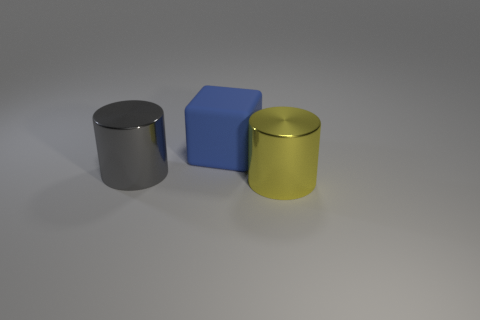Subtract all cubes. How many objects are left? 2 Subtract 1 cylinders. How many cylinders are left? 1 Add 3 large brown matte cylinders. How many objects exist? 6 Subtract 1 gray cylinders. How many objects are left? 2 Subtract all red cylinders. Subtract all red spheres. How many cylinders are left? 2 Subtract all red balls. How many red cubes are left? 0 Subtract all large shiny cubes. Subtract all big yellow shiny objects. How many objects are left? 2 Add 3 big gray things. How many big gray things are left? 4 Add 2 gray metallic cubes. How many gray metallic cubes exist? 2 